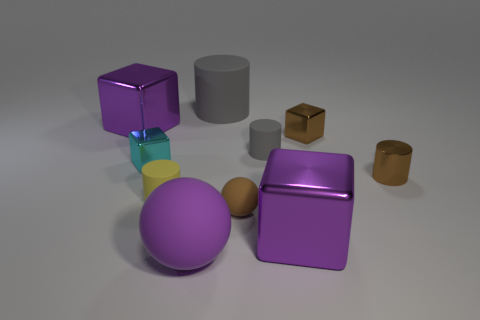What is the material of the sphere that is the same color as the tiny shiny cylinder?
Your answer should be compact. Rubber. Is the metal cylinder the same color as the small ball?
Your answer should be compact. Yes. What number of other balls are the same material as the brown sphere?
Keep it short and to the point. 1. What number of objects are big blocks right of the yellow matte cylinder or things that are on the right side of the small cyan shiny thing?
Ensure brevity in your answer.  8. Are there more gray cylinders that are right of the small brown rubber ball than large purple things that are in front of the purple rubber thing?
Your answer should be compact. Yes. There is a big shiny object that is left of the purple rubber object; what is its color?
Offer a very short reply. Purple. Is there another thing that has the same shape as the brown matte object?
Offer a terse response. Yes. How many brown objects are either big rubber objects or large spheres?
Your answer should be compact. 0. Are there any purple shiny cylinders that have the same size as the purple rubber object?
Your response must be concise. No. How many gray metallic cylinders are there?
Offer a terse response. 0. 